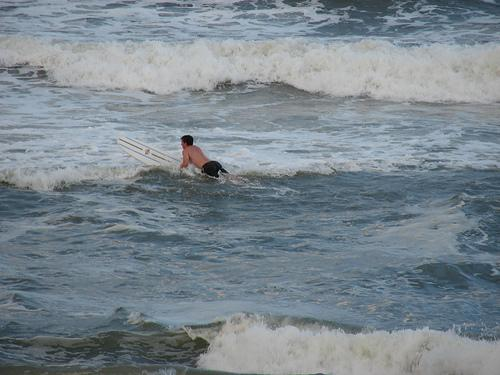Question: what color is the water?
Choices:
A. Brown.
B. Green.
C. White.
D. Blue.
Answer with the letter. Answer: D Question: what color is his board?
Choices:
A. Red.
B. White.
C. Yellow.
D. Blue.
Answer with the letter. Answer: B Question: who is the subject of this photo?
Choices:
A. The surfer.
B. The sunbather.
C. The toddler.
D. The lifeguard.
Answer with the letter. Answer: A Question: when was this photo taken?
Choices:
A. At night.
B. At noon.
C. During the day.
D. At sunset.
Answer with the letter. Answer: C Question: what color are his shorts?
Choices:
A. Red.
B. Yellow.
C. Blue.
D. Black.
Answer with the letter. Answer: D Question: why is this photo illuminated?
Choices:
A. Moonlight.
B. Reflective light.
C. Sunlight.
D. Torchlight.
Answer with the letter. Answer: C Question: where was this photo taken?
Choices:
A. In the forest.
B. In the jungle.
C. In the park.
D. In the ocean.
Answer with the letter. Answer: D 